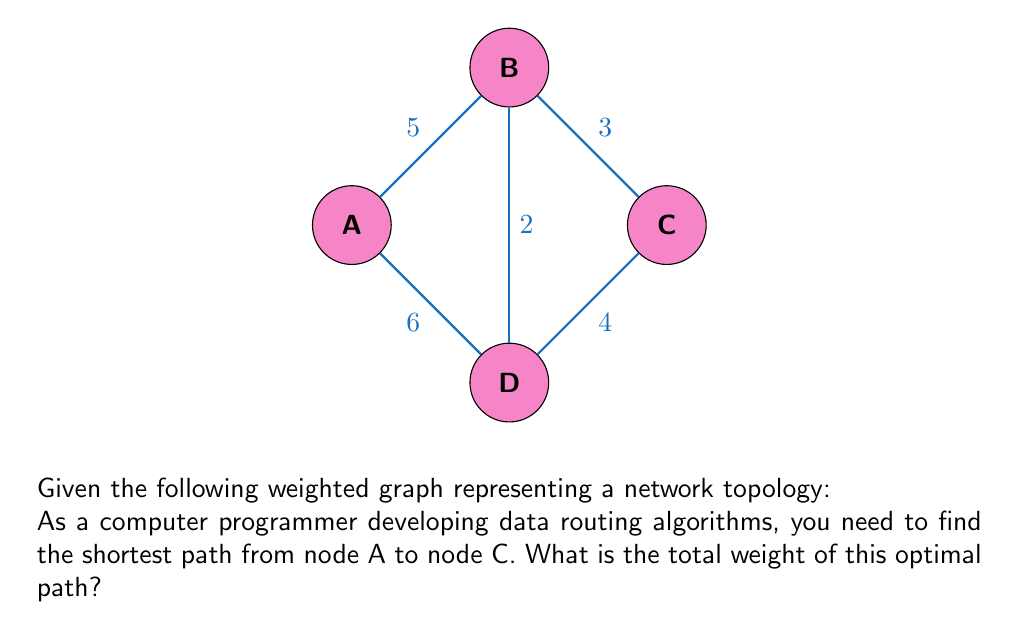Can you answer this question? To solve this problem, we'll use Dijkstra's algorithm, which is commonly used in data routing to find the shortest path in a weighted graph.

Step 1: Initialize distances
Set distance to A as 0, and all other nodes as infinity.
$$d(A) = 0, d(B) = \infty, d(C) = \infty, d(D) = \infty$$

Step 2: Visit node A
Update distances to neighbors:
$$d(B) = \min(\infty, 0 + 5) = 5$$
$$d(D) = \min(\infty, 0 + 6) = 6$$

Step 3: Visit node B (closest unvisited node)
Update distances:
$$d(C) = \min(\infty, 5 + 3) = 8$$
$$d(D) = \min(6, 5 + 2) = 5$$

Step 4: Visit node D
No updates needed as all paths through D are longer.

Step 5: Visit node C
This is our target node, so we stop here.

The shortest path from A to C is A → B → C with a total weight of 8.
Answer: 8 